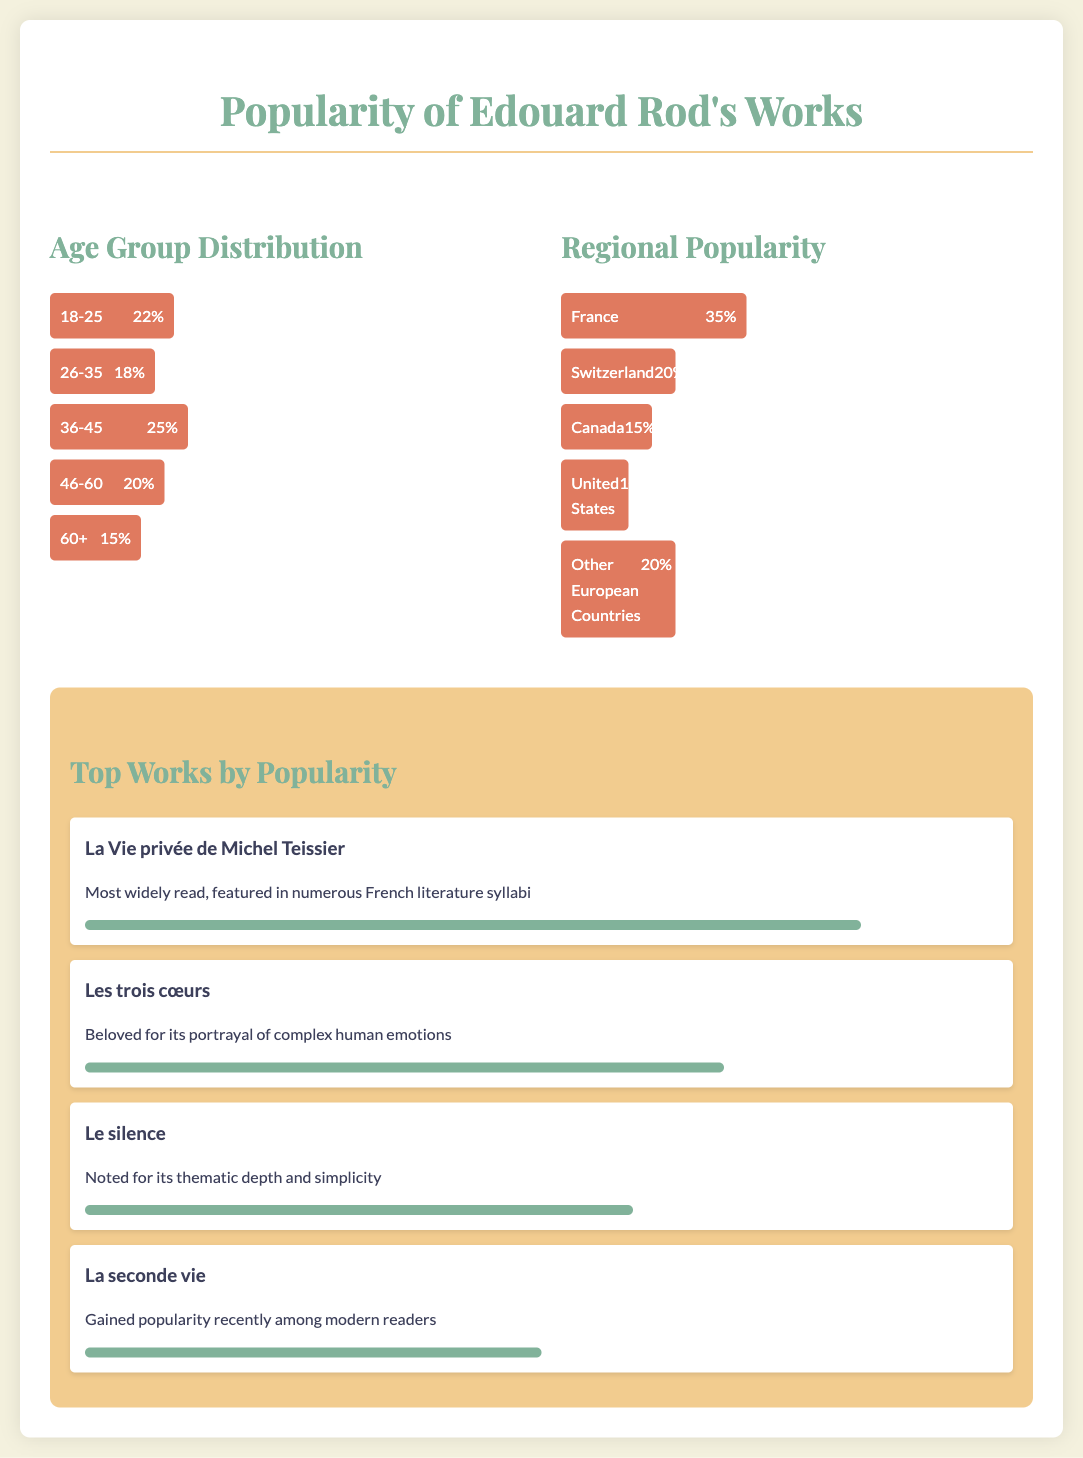What age group has the highest percentage of readership? The age group with the highest readership percentage is determined from the Age Group Distribution bar chart, where 36-45 years holds the maximum share.
Answer: 36-45 What percentage of readers are aged 18-25? The document provides the specific percentage of readers aged 18-25 from the Age Group Distribution, which is noted directly on the chart.
Answer: 22% Which work is noted as the most widely read? The most widely read work is stated in the Top Works by Popularity section, which highlights its prominence in French literature syllabi.
Answer: La Vie privée de Michel Teissier What percentage of readers in Canada enjoy Edouard Rod's works? The percentage of readers in Canada is explicitly given in the Regional Popularity chart of the document.
Answer: 15% Which region has the lowest readership percentage? The region with the lowest readership percentage is identified through comparing the values in the Regional Popularity chart.
Answer: United States What is the popularity percentage of "Les trois cœurs"? The popularity percentage of "Les trois cœurs" is provided directly in the context of Top Works by Popularity.
Answer: 70% Which age group accounts for 20% of Edouard Rod's readership? The specific age group that accounts for 20% can be identified from the Age Group Distribution chart presented in the infographic.
Answer: 46-60 What is the percentage of Edouard Rod's readership in France? The percentage of readership in France is explicitly mentioned in the Regional Popularity chart, which directly indicates the figure.
Answer: 35% Which work gained popularity recently among modern readers? The work that has gained popularity recently is conclusively stated in the Top Works by Popularity section, denoting its rising interest.
Answer: La seconde vie 